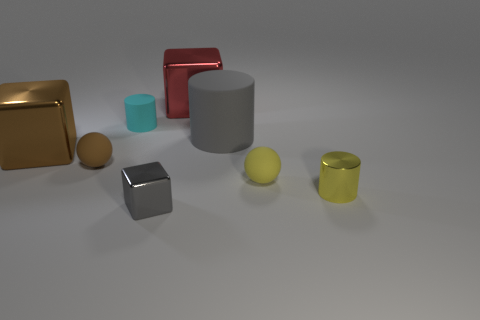If you had to guess, what materials do the objects in the image seem to be made of? Based on their appearances, the gold and silver cubes look like they could be made of metal due to their reflective surfaces. The cyan and yellow cylinders and the ball seem like they could be made of a matte plastic or painted wood, as they have a less reflective, more uniformly colored finish. 